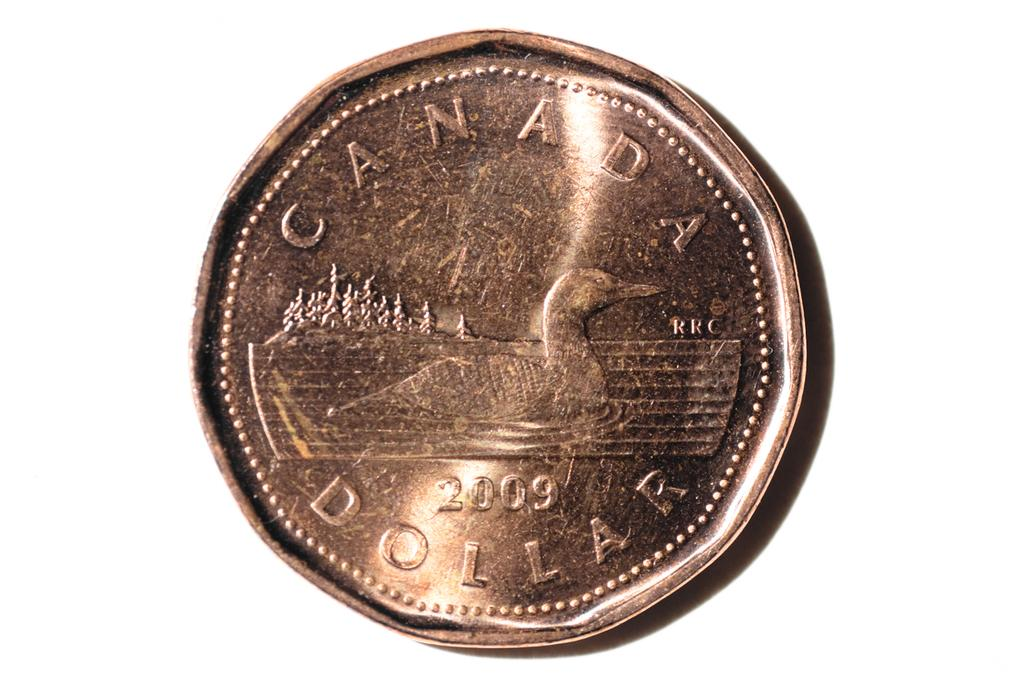<image>
Create a compact narrative representing the image presented. A Canada dollar coin is from the year 2009. 